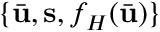<formula> <loc_0><loc_0><loc_500><loc_500>\{ \bar { u } , s , f _ { H } ( \bar { u } ) \}</formula> 